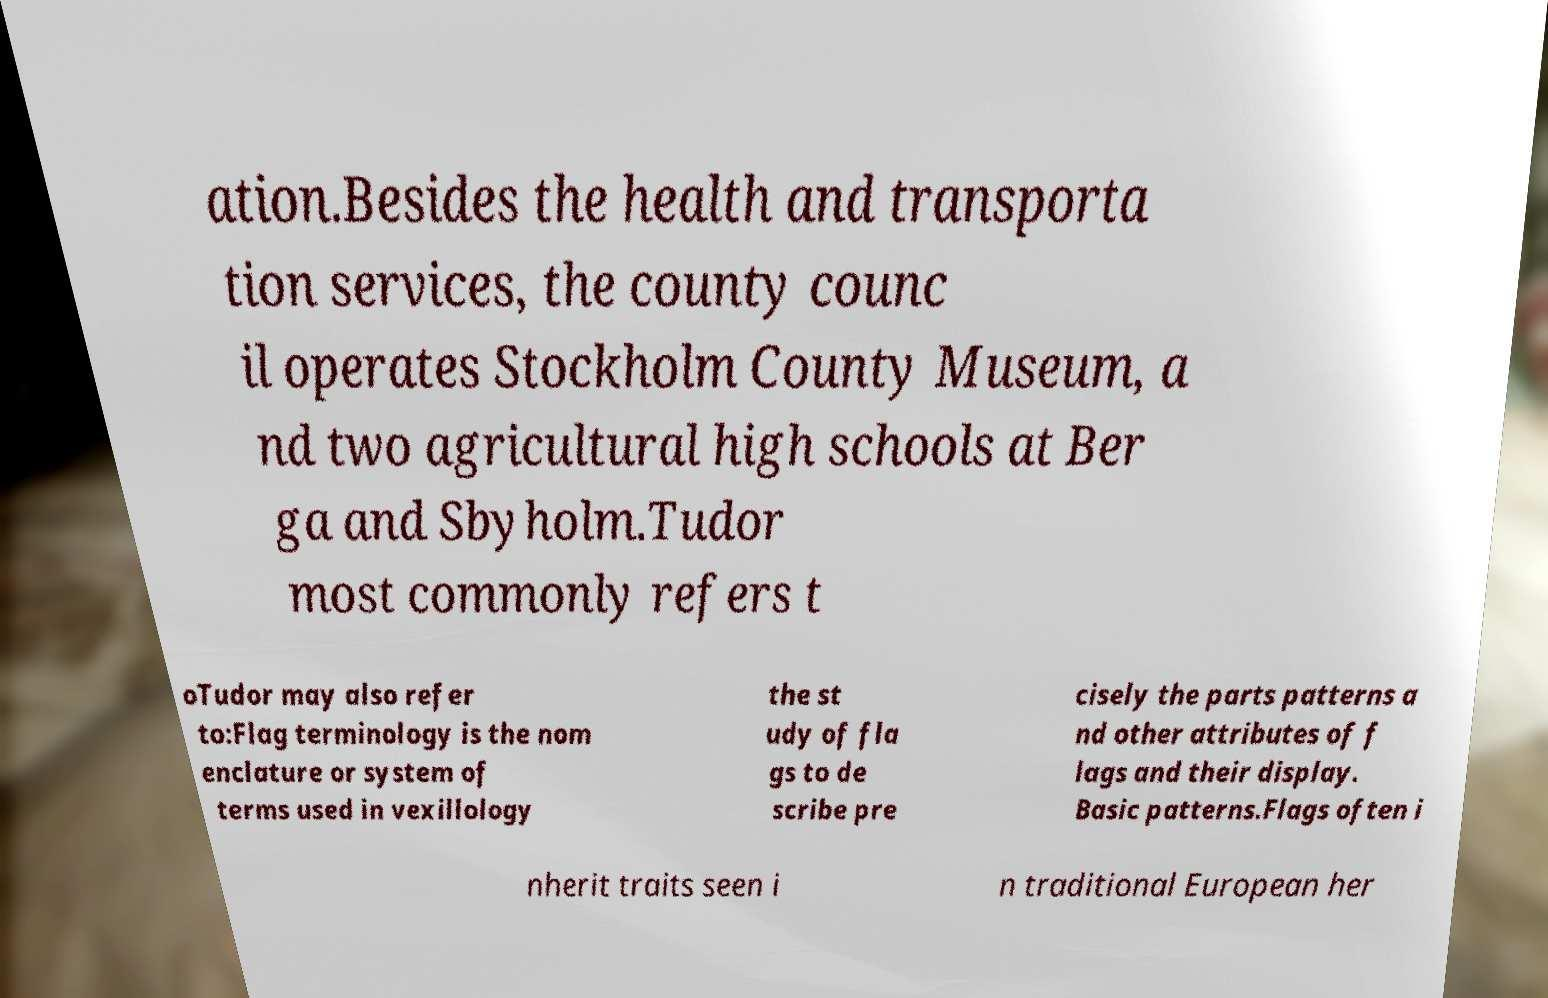There's text embedded in this image that I need extracted. Can you transcribe it verbatim? ation.Besides the health and transporta tion services, the county counc il operates Stockholm County Museum, a nd two agricultural high schools at Ber ga and Sbyholm.Tudor most commonly refers t oTudor may also refer to:Flag terminology is the nom enclature or system of terms used in vexillology the st udy of fla gs to de scribe pre cisely the parts patterns a nd other attributes of f lags and their display. Basic patterns.Flags often i nherit traits seen i n traditional European her 